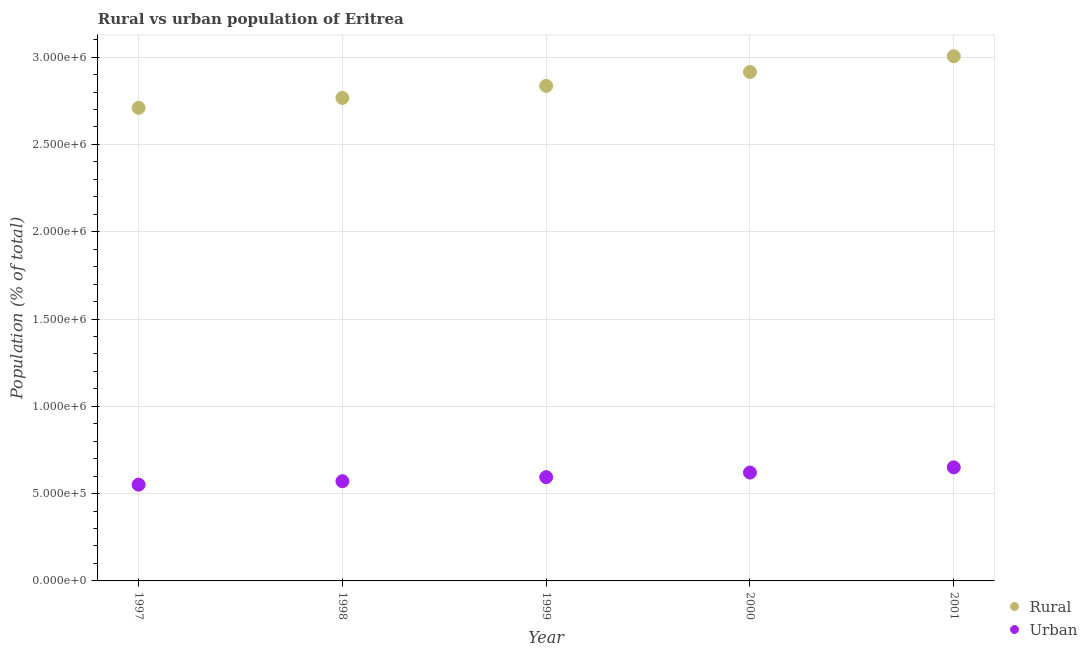How many different coloured dotlines are there?
Your answer should be very brief. 2. Is the number of dotlines equal to the number of legend labels?
Ensure brevity in your answer.  Yes. What is the rural population density in 1998?
Ensure brevity in your answer.  2.77e+06. Across all years, what is the maximum urban population density?
Provide a short and direct response. 6.50e+05. Across all years, what is the minimum urban population density?
Make the answer very short. 5.51e+05. In which year was the urban population density minimum?
Give a very brief answer. 1997. What is the total urban population density in the graph?
Offer a terse response. 2.99e+06. What is the difference between the rural population density in 1997 and that in 1999?
Provide a short and direct response. -1.26e+05. What is the difference between the urban population density in 2001 and the rural population density in 1998?
Provide a short and direct response. -2.12e+06. What is the average urban population density per year?
Provide a succinct answer. 5.98e+05. In the year 1998, what is the difference between the rural population density and urban population density?
Your answer should be very brief. 2.20e+06. What is the ratio of the urban population density in 1998 to that in 1999?
Give a very brief answer. 0.96. Is the urban population density in 1998 less than that in 1999?
Provide a short and direct response. Yes. Is the difference between the urban population density in 1997 and 1999 greater than the difference between the rural population density in 1997 and 1999?
Provide a succinct answer. Yes. What is the difference between the highest and the second highest rural population density?
Give a very brief answer. 9.00e+04. What is the difference between the highest and the lowest rural population density?
Keep it short and to the point. 2.95e+05. In how many years, is the urban population density greater than the average urban population density taken over all years?
Your response must be concise. 2. Does the urban population density monotonically increase over the years?
Your answer should be compact. Yes. Is the urban population density strictly greater than the rural population density over the years?
Provide a succinct answer. No. How many dotlines are there?
Make the answer very short. 2. How many years are there in the graph?
Offer a terse response. 5. Does the graph contain any zero values?
Your answer should be compact. No. Where does the legend appear in the graph?
Ensure brevity in your answer.  Bottom right. How are the legend labels stacked?
Ensure brevity in your answer.  Vertical. What is the title of the graph?
Offer a terse response. Rural vs urban population of Eritrea. What is the label or title of the X-axis?
Ensure brevity in your answer.  Year. What is the label or title of the Y-axis?
Ensure brevity in your answer.  Population (% of total). What is the Population (% of total) in Rural in 1997?
Your answer should be compact. 2.71e+06. What is the Population (% of total) of Urban in 1997?
Ensure brevity in your answer.  5.51e+05. What is the Population (% of total) in Rural in 1998?
Make the answer very short. 2.77e+06. What is the Population (% of total) of Urban in 1998?
Your answer should be very brief. 5.71e+05. What is the Population (% of total) in Rural in 1999?
Your answer should be very brief. 2.84e+06. What is the Population (% of total) of Urban in 1999?
Make the answer very short. 5.94e+05. What is the Population (% of total) in Rural in 2000?
Ensure brevity in your answer.  2.91e+06. What is the Population (% of total) of Urban in 2000?
Your response must be concise. 6.21e+05. What is the Population (% of total) in Rural in 2001?
Offer a very short reply. 3.00e+06. What is the Population (% of total) of Urban in 2001?
Make the answer very short. 6.50e+05. Across all years, what is the maximum Population (% of total) of Rural?
Give a very brief answer. 3.00e+06. Across all years, what is the maximum Population (% of total) of Urban?
Provide a short and direct response. 6.50e+05. Across all years, what is the minimum Population (% of total) of Rural?
Provide a succinct answer. 2.71e+06. Across all years, what is the minimum Population (% of total) in Urban?
Ensure brevity in your answer.  5.51e+05. What is the total Population (% of total) of Rural in the graph?
Keep it short and to the point. 1.42e+07. What is the total Population (% of total) in Urban in the graph?
Offer a terse response. 2.99e+06. What is the difference between the Population (% of total) in Rural in 1997 and that in 1998?
Offer a very short reply. -5.69e+04. What is the difference between the Population (% of total) of Urban in 1997 and that in 1998?
Your answer should be compact. -1.98e+04. What is the difference between the Population (% of total) in Rural in 1997 and that in 1999?
Your answer should be compact. -1.26e+05. What is the difference between the Population (% of total) in Urban in 1997 and that in 1999?
Your response must be concise. -4.30e+04. What is the difference between the Population (% of total) of Rural in 1997 and that in 2000?
Your answer should be very brief. -2.05e+05. What is the difference between the Population (% of total) in Urban in 1997 and that in 2000?
Give a very brief answer. -6.93e+04. What is the difference between the Population (% of total) in Rural in 1997 and that in 2001?
Provide a short and direct response. -2.95e+05. What is the difference between the Population (% of total) of Urban in 1997 and that in 2001?
Give a very brief answer. -9.91e+04. What is the difference between the Population (% of total) in Rural in 1998 and that in 1999?
Make the answer very short. -6.92e+04. What is the difference between the Population (% of total) of Urban in 1998 and that in 1999?
Offer a very short reply. -2.32e+04. What is the difference between the Population (% of total) in Rural in 1998 and that in 2000?
Give a very brief answer. -1.48e+05. What is the difference between the Population (% of total) in Urban in 1998 and that in 2000?
Provide a short and direct response. -4.95e+04. What is the difference between the Population (% of total) in Rural in 1998 and that in 2001?
Your answer should be compact. -2.38e+05. What is the difference between the Population (% of total) in Urban in 1998 and that in 2001?
Make the answer very short. -7.94e+04. What is the difference between the Population (% of total) in Rural in 1999 and that in 2000?
Provide a short and direct response. -7.92e+04. What is the difference between the Population (% of total) of Urban in 1999 and that in 2000?
Your answer should be compact. -2.63e+04. What is the difference between the Population (% of total) in Rural in 1999 and that in 2001?
Make the answer very short. -1.69e+05. What is the difference between the Population (% of total) of Urban in 1999 and that in 2001?
Give a very brief answer. -5.62e+04. What is the difference between the Population (% of total) in Rural in 2000 and that in 2001?
Offer a very short reply. -9.00e+04. What is the difference between the Population (% of total) of Urban in 2000 and that in 2001?
Your answer should be very brief. -2.98e+04. What is the difference between the Population (% of total) in Rural in 1997 and the Population (% of total) in Urban in 1998?
Your answer should be compact. 2.14e+06. What is the difference between the Population (% of total) of Rural in 1997 and the Population (% of total) of Urban in 1999?
Your response must be concise. 2.12e+06. What is the difference between the Population (% of total) in Rural in 1997 and the Population (% of total) in Urban in 2000?
Your answer should be compact. 2.09e+06. What is the difference between the Population (% of total) in Rural in 1997 and the Population (% of total) in Urban in 2001?
Your answer should be compact. 2.06e+06. What is the difference between the Population (% of total) in Rural in 1998 and the Population (% of total) in Urban in 1999?
Your answer should be compact. 2.17e+06. What is the difference between the Population (% of total) of Rural in 1998 and the Population (% of total) of Urban in 2000?
Your answer should be very brief. 2.15e+06. What is the difference between the Population (% of total) in Rural in 1998 and the Population (% of total) in Urban in 2001?
Keep it short and to the point. 2.12e+06. What is the difference between the Population (% of total) in Rural in 1999 and the Population (% of total) in Urban in 2000?
Your answer should be compact. 2.21e+06. What is the difference between the Population (% of total) in Rural in 1999 and the Population (% of total) in Urban in 2001?
Make the answer very short. 2.18e+06. What is the difference between the Population (% of total) in Rural in 2000 and the Population (% of total) in Urban in 2001?
Provide a short and direct response. 2.26e+06. What is the average Population (% of total) in Rural per year?
Ensure brevity in your answer.  2.85e+06. What is the average Population (% of total) of Urban per year?
Ensure brevity in your answer.  5.98e+05. In the year 1997, what is the difference between the Population (% of total) of Rural and Population (% of total) of Urban?
Your answer should be very brief. 2.16e+06. In the year 1998, what is the difference between the Population (% of total) of Rural and Population (% of total) of Urban?
Your answer should be compact. 2.20e+06. In the year 1999, what is the difference between the Population (% of total) of Rural and Population (% of total) of Urban?
Your response must be concise. 2.24e+06. In the year 2000, what is the difference between the Population (% of total) of Rural and Population (% of total) of Urban?
Provide a succinct answer. 2.29e+06. In the year 2001, what is the difference between the Population (% of total) of Rural and Population (% of total) of Urban?
Offer a very short reply. 2.35e+06. What is the ratio of the Population (% of total) of Rural in 1997 to that in 1998?
Keep it short and to the point. 0.98. What is the ratio of the Population (% of total) in Urban in 1997 to that in 1998?
Offer a very short reply. 0.97. What is the ratio of the Population (% of total) of Rural in 1997 to that in 1999?
Your response must be concise. 0.96. What is the ratio of the Population (% of total) of Urban in 1997 to that in 1999?
Provide a succinct answer. 0.93. What is the ratio of the Population (% of total) in Rural in 1997 to that in 2000?
Offer a very short reply. 0.93. What is the ratio of the Population (% of total) of Urban in 1997 to that in 2000?
Your answer should be very brief. 0.89. What is the ratio of the Population (% of total) in Rural in 1997 to that in 2001?
Your answer should be compact. 0.9. What is the ratio of the Population (% of total) of Urban in 1997 to that in 2001?
Ensure brevity in your answer.  0.85. What is the ratio of the Population (% of total) of Rural in 1998 to that in 1999?
Your answer should be compact. 0.98. What is the ratio of the Population (% of total) in Urban in 1998 to that in 1999?
Keep it short and to the point. 0.96. What is the ratio of the Population (% of total) of Rural in 1998 to that in 2000?
Provide a short and direct response. 0.95. What is the ratio of the Population (% of total) of Urban in 1998 to that in 2000?
Make the answer very short. 0.92. What is the ratio of the Population (% of total) of Rural in 1998 to that in 2001?
Keep it short and to the point. 0.92. What is the ratio of the Population (% of total) in Urban in 1998 to that in 2001?
Give a very brief answer. 0.88. What is the ratio of the Population (% of total) of Rural in 1999 to that in 2000?
Your response must be concise. 0.97. What is the ratio of the Population (% of total) of Urban in 1999 to that in 2000?
Provide a short and direct response. 0.96. What is the ratio of the Population (% of total) of Rural in 1999 to that in 2001?
Your response must be concise. 0.94. What is the ratio of the Population (% of total) in Urban in 1999 to that in 2001?
Keep it short and to the point. 0.91. What is the ratio of the Population (% of total) in Rural in 2000 to that in 2001?
Your answer should be compact. 0.97. What is the ratio of the Population (% of total) of Urban in 2000 to that in 2001?
Give a very brief answer. 0.95. What is the difference between the highest and the second highest Population (% of total) of Rural?
Keep it short and to the point. 9.00e+04. What is the difference between the highest and the second highest Population (% of total) of Urban?
Your answer should be compact. 2.98e+04. What is the difference between the highest and the lowest Population (% of total) in Rural?
Provide a short and direct response. 2.95e+05. What is the difference between the highest and the lowest Population (% of total) of Urban?
Offer a very short reply. 9.91e+04. 